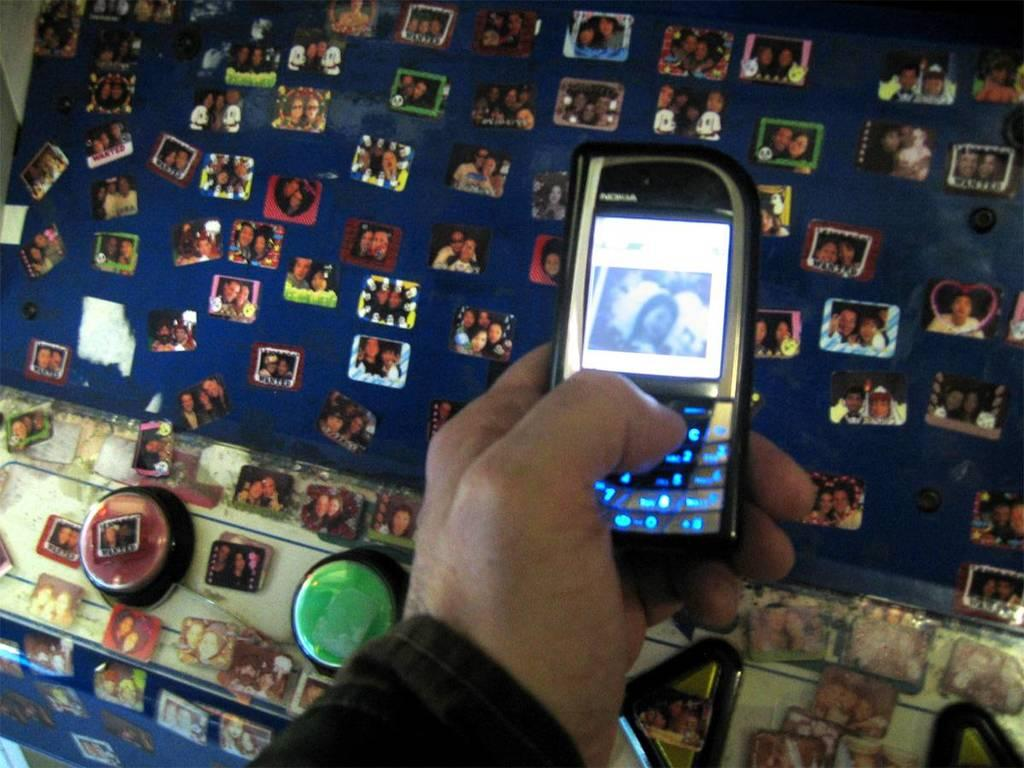<image>
Summarize the visual content of the image. a person looking at a photo on a Nokia phone 